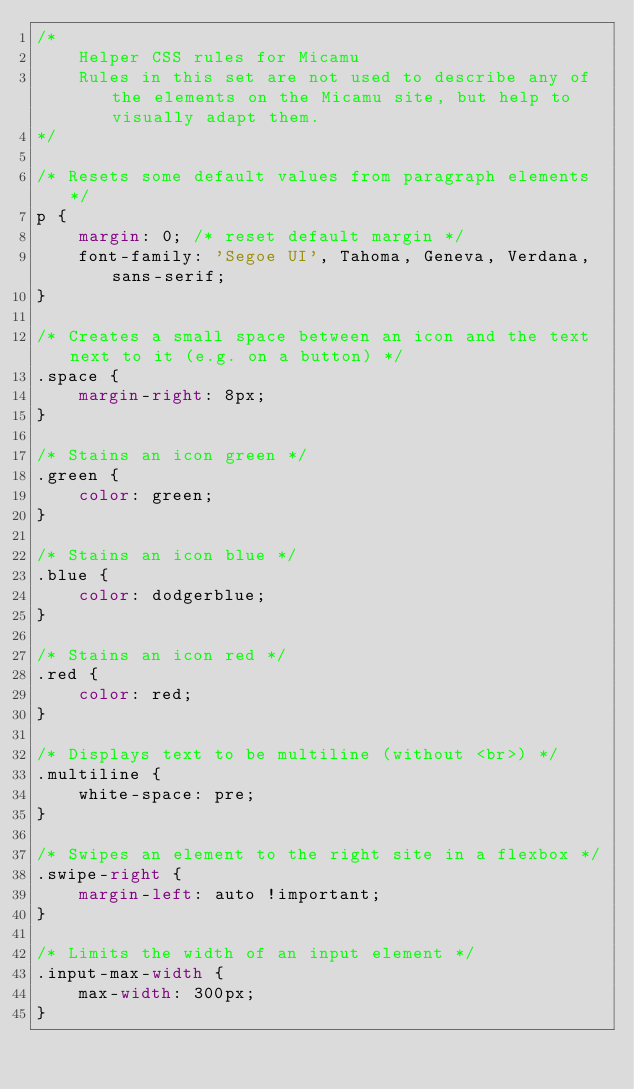<code> <loc_0><loc_0><loc_500><loc_500><_CSS_>/*
    Helper CSS rules for Micamu
    Rules in this set are not used to describe any of the elements on the Micamu site, but help to visually adapt them.
*/

/* Resets some default values from paragraph elements */
p {
    margin: 0; /* reset default margin */
    font-family: 'Segoe UI', Tahoma, Geneva, Verdana, sans-serif;
}

/* Creates a small space between an icon and the text next to it (e.g. on a button) */
.space { 
    margin-right: 8px;
}

/* Stains an icon green */
.green {
    color: green;
}

/* Stains an icon blue */
.blue {
    color: dodgerblue;
}

/* Stains an icon red */
.red {
    color: red;
}

/* Displays text to be multiline (without <br>) */
.multiline {
    white-space: pre;
}

/* Swipes an element to the right site in a flexbox */
.swipe-right {
    margin-left: auto !important;
}

/* Limits the width of an input element */
.input-max-width {
    max-width: 300px;
}</code> 